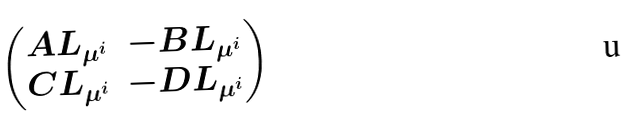<formula> <loc_0><loc_0><loc_500><loc_500>\begin{pmatrix} A L _ { \mu ^ { i } } & - B L _ { \mu ^ { i } } \\ C L _ { \mu ^ { i } } & - D L _ { \mu ^ { i } } \end{pmatrix}</formula> 